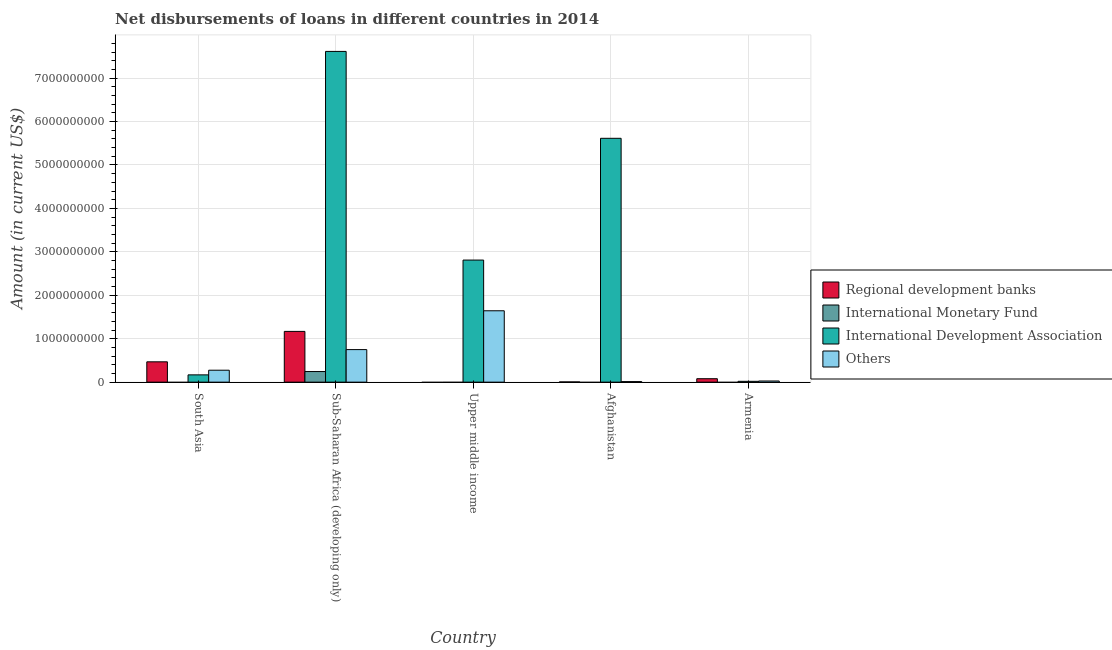How many different coloured bars are there?
Offer a very short reply. 4. How many groups of bars are there?
Your answer should be very brief. 5. Are the number of bars per tick equal to the number of legend labels?
Give a very brief answer. No. Are the number of bars on each tick of the X-axis equal?
Your answer should be very brief. No. What is the label of the 5th group of bars from the left?
Ensure brevity in your answer.  Armenia. What is the amount of loan disimbursed by international development association in Armenia?
Keep it short and to the point. 1.91e+07. Across all countries, what is the maximum amount of loan disimbursed by other organisations?
Provide a short and direct response. 1.64e+09. Across all countries, what is the minimum amount of loan disimbursed by other organisations?
Your answer should be compact. 1.25e+07. In which country was the amount of loan disimbursed by regional development banks maximum?
Provide a succinct answer. Sub-Saharan Africa (developing only). What is the total amount of loan disimbursed by regional development banks in the graph?
Give a very brief answer. 1.72e+09. What is the difference between the amount of loan disimbursed by other organisations in South Asia and that in Upper middle income?
Give a very brief answer. -1.37e+09. What is the difference between the amount of loan disimbursed by international development association in Upper middle income and the amount of loan disimbursed by regional development banks in Sub-Saharan Africa (developing only)?
Your answer should be very brief. 1.64e+09. What is the average amount of loan disimbursed by other organisations per country?
Offer a very short reply. 5.41e+08. What is the difference between the amount of loan disimbursed by other organisations and amount of loan disimbursed by regional development banks in Sub-Saharan Africa (developing only)?
Keep it short and to the point. -4.19e+08. In how many countries, is the amount of loan disimbursed by regional development banks greater than 1800000000 US$?
Offer a terse response. 0. What is the ratio of the amount of loan disimbursed by international development association in South Asia to that in Upper middle income?
Offer a terse response. 0.06. Is the amount of loan disimbursed by regional development banks in Afghanistan less than that in Sub-Saharan Africa (developing only)?
Give a very brief answer. Yes. What is the difference between the highest and the second highest amount of loan disimbursed by other organisations?
Make the answer very short. 8.94e+08. What is the difference between the highest and the lowest amount of loan disimbursed by international development association?
Make the answer very short. 7.59e+09. Is it the case that in every country, the sum of the amount of loan disimbursed by regional development banks and amount of loan disimbursed by international monetary fund is greater than the amount of loan disimbursed by international development association?
Your answer should be very brief. No. Does the graph contain any zero values?
Your answer should be very brief. Yes. Does the graph contain grids?
Give a very brief answer. Yes. Where does the legend appear in the graph?
Your response must be concise. Center right. What is the title of the graph?
Offer a terse response. Net disbursements of loans in different countries in 2014. Does "Budget management" appear as one of the legend labels in the graph?
Make the answer very short. No. What is the label or title of the Y-axis?
Provide a short and direct response. Amount (in current US$). What is the Amount (in current US$) of Regional development banks in South Asia?
Provide a short and direct response. 4.68e+08. What is the Amount (in current US$) in International Development Association in South Asia?
Ensure brevity in your answer.  1.68e+08. What is the Amount (in current US$) of Others in South Asia?
Make the answer very short. 2.75e+08. What is the Amount (in current US$) of Regional development banks in Sub-Saharan Africa (developing only)?
Make the answer very short. 1.17e+09. What is the Amount (in current US$) of International Monetary Fund in Sub-Saharan Africa (developing only)?
Ensure brevity in your answer.  2.44e+08. What is the Amount (in current US$) of International Development Association in Sub-Saharan Africa (developing only)?
Your answer should be compact. 7.61e+09. What is the Amount (in current US$) of Others in Sub-Saharan Africa (developing only)?
Your response must be concise. 7.49e+08. What is the Amount (in current US$) of International Monetary Fund in Upper middle income?
Provide a succinct answer. 0. What is the Amount (in current US$) in International Development Association in Upper middle income?
Ensure brevity in your answer.  2.81e+09. What is the Amount (in current US$) of Others in Upper middle income?
Offer a terse response. 1.64e+09. What is the Amount (in current US$) in Regional development banks in Afghanistan?
Offer a very short reply. 5.16e+06. What is the Amount (in current US$) in International Development Association in Afghanistan?
Offer a terse response. 5.61e+09. What is the Amount (in current US$) in Others in Afghanistan?
Provide a succinct answer. 1.25e+07. What is the Amount (in current US$) in Regional development banks in Armenia?
Offer a terse response. 7.92e+07. What is the Amount (in current US$) of International Development Association in Armenia?
Provide a short and direct response. 1.91e+07. What is the Amount (in current US$) in Others in Armenia?
Ensure brevity in your answer.  2.65e+07. Across all countries, what is the maximum Amount (in current US$) in Regional development banks?
Give a very brief answer. 1.17e+09. Across all countries, what is the maximum Amount (in current US$) of International Monetary Fund?
Offer a terse response. 2.44e+08. Across all countries, what is the maximum Amount (in current US$) in International Development Association?
Offer a terse response. 7.61e+09. Across all countries, what is the maximum Amount (in current US$) in Others?
Offer a very short reply. 1.64e+09. Across all countries, what is the minimum Amount (in current US$) in Regional development banks?
Ensure brevity in your answer.  0. Across all countries, what is the minimum Amount (in current US$) of International Development Association?
Provide a succinct answer. 1.91e+07. Across all countries, what is the minimum Amount (in current US$) in Others?
Ensure brevity in your answer.  1.25e+07. What is the total Amount (in current US$) in Regional development banks in the graph?
Offer a very short reply. 1.72e+09. What is the total Amount (in current US$) in International Monetary Fund in the graph?
Your answer should be very brief. 2.44e+08. What is the total Amount (in current US$) in International Development Association in the graph?
Give a very brief answer. 1.62e+1. What is the total Amount (in current US$) in Others in the graph?
Your answer should be very brief. 2.71e+09. What is the difference between the Amount (in current US$) in Regional development banks in South Asia and that in Sub-Saharan Africa (developing only)?
Provide a short and direct response. -7.01e+08. What is the difference between the Amount (in current US$) in International Development Association in South Asia and that in Sub-Saharan Africa (developing only)?
Offer a terse response. -7.45e+09. What is the difference between the Amount (in current US$) in Others in South Asia and that in Sub-Saharan Africa (developing only)?
Give a very brief answer. -4.75e+08. What is the difference between the Amount (in current US$) of International Development Association in South Asia and that in Upper middle income?
Ensure brevity in your answer.  -2.64e+09. What is the difference between the Amount (in current US$) in Others in South Asia and that in Upper middle income?
Keep it short and to the point. -1.37e+09. What is the difference between the Amount (in current US$) of Regional development banks in South Asia and that in Afghanistan?
Make the answer very short. 4.63e+08. What is the difference between the Amount (in current US$) of International Development Association in South Asia and that in Afghanistan?
Offer a very short reply. -5.45e+09. What is the difference between the Amount (in current US$) in Others in South Asia and that in Afghanistan?
Keep it short and to the point. 2.62e+08. What is the difference between the Amount (in current US$) of Regional development banks in South Asia and that in Armenia?
Provide a short and direct response. 3.89e+08. What is the difference between the Amount (in current US$) in International Development Association in South Asia and that in Armenia?
Your answer should be very brief. 1.49e+08. What is the difference between the Amount (in current US$) in Others in South Asia and that in Armenia?
Offer a very short reply. 2.48e+08. What is the difference between the Amount (in current US$) of International Development Association in Sub-Saharan Africa (developing only) and that in Upper middle income?
Ensure brevity in your answer.  4.80e+09. What is the difference between the Amount (in current US$) in Others in Sub-Saharan Africa (developing only) and that in Upper middle income?
Ensure brevity in your answer.  -8.94e+08. What is the difference between the Amount (in current US$) in Regional development banks in Sub-Saharan Africa (developing only) and that in Afghanistan?
Your response must be concise. 1.16e+09. What is the difference between the Amount (in current US$) in International Development Association in Sub-Saharan Africa (developing only) and that in Afghanistan?
Your response must be concise. 2.00e+09. What is the difference between the Amount (in current US$) in Others in Sub-Saharan Africa (developing only) and that in Afghanistan?
Provide a succinct answer. 7.37e+08. What is the difference between the Amount (in current US$) in Regional development banks in Sub-Saharan Africa (developing only) and that in Armenia?
Make the answer very short. 1.09e+09. What is the difference between the Amount (in current US$) of International Development Association in Sub-Saharan Africa (developing only) and that in Armenia?
Ensure brevity in your answer.  7.59e+09. What is the difference between the Amount (in current US$) in Others in Sub-Saharan Africa (developing only) and that in Armenia?
Your answer should be very brief. 7.23e+08. What is the difference between the Amount (in current US$) of International Development Association in Upper middle income and that in Afghanistan?
Provide a short and direct response. -2.80e+09. What is the difference between the Amount (in current US$) of Others in Upper middle income and that in Afghanistan?
Give a very brief answer. 1.63e+09. What is the difference between the Amount (in current US$) of International Development Association in Upper middle income and that in Armenia?
Offer a terse response. 2.79e+09. What is the difference between the Amount (in current US$) of Others in Upper middle income and that in Armenia?
Your response must be concise. 1.62e+09. What is the difference between the Amount (in current US$) in Regional development banks in Afghanistan and that in Armenia?
Provide a short and direct response. -7.40e+07. What is the difference between the Amount (in current US$) of International Development Association in Afghanistan and that in Armenia?
Make the answer very short. 5.59e+09. What is the difference between the Amount (in current US$) of Others in Afghanistan and that in Armenia?
Your response must be concise. -1.40e+07. What is the difference between the Amount (in current US$) in Regional development banks in South Asia and the Amount (in current US$) in International Monetary Fund in Sub-Saharan Africa (developing only)?
Provide a short and direct response. 2.24e+08. What is the difference between the Amount (in current US$) in Regional development banks in South Asia and the Amount (in current US$) in International Development Association in Sub-Saharan Africa (developing only)?
Your response must be concise. -7.15e+09. What is the difference between the Amount (in current US$) in Regional development banks in South Asia and the Amount (in current US$) in Others in Sub-Saharan Africa (developing only)?
Your answer should be compact. -2.82e+08. What is the difference between the Amount (in current US$) in International Development Association in South Asia and the Amount (in current US$) in Others in Sub-Saharan Africa (developing only)?
Make the answer very short. -5.82e+08. What is the difference between the Amount (in current US$) in Regional development banks in South Asia and the Amount (in current US$) in International Development Association in Upper middle income?
Offer a terse response. -2.34e+09. What is the difference between the Amount (in current US$) of Regional development banks in South Asia and the Amount (in current US$) of Others in Upper middle income?
Your response must be concise. -1.18e+09. What is the difference between the Amount (in current US$) of International Development Association in South Asia and the Amount (in current US$) of Others in Upper middle income?
Your answer should be very brief. -1.48e+09. What is the difference between the Amount (in current US$) of Regional development banks in South Asia and the Amount (in current US$) of International Development Association in Afghanistan?
Your answer should be compact. -5.15e+09. What is the difference between the Amount (in current US$) of Regional development banks in South Asia and the Amount (in current US$) of Others in Afghanistan?
Your response must be concise. 4.55e+08. What is the difference between the Amount (in current US$) of International Development Association in South Asia and the Amount (in current US$) of Others in Afghanistan?
Ensure brevity in your answer.  1.55e+08. What is the difference between the Amount (in current US$) in Regional development banks in South Asia and the Amount (in current US$) in International Development Association in Armenia?
Make the answer very short. 4.49e+08. What is the difference between the Amount (in current US$) of Regional development banks in South Asia and the Amount (in current US$) of Others in Armenia?
Your response must be concise. 4.41e+08. What is the difference between the Amount (in current US$) in International Development Association in South Asia and the Amount (in current US$) in Others in Armenia?
Offer a terse response. 1.41e+08. What is the difference between the Amount (in current US$) of Regional development banks in Sub-Saharan Africa (developing only) and the Amount (in current US$) of International Development Association in Upper middle income?
Your answer should be compact. -1.64e+09. What is the difference between the Amount (in current US$) in Regional development banks in Sub-Saharan Africa (developing only) and the Amount (in current US$) in Others in Upper middle income?
Your answer should be compact. -4.75e+08. What is the difference between the Amount (in current US$) of International Monetary Fund in Sub-Saharan Africa (developing only) and the Amount (in current US$) of International Development Association in Upper middle income?
Offer a terse response. -2.57e+09. What is the difference between the Amount (in current US$) in International Monetary Fund in Sub-Saharan Africa (developing only) and the Amount (in current US$) in Others in Upper middle income?
Your answer should be compact. -1.40e+09. What is the difference between the Amount (in current US$) in International Development Association in Sub-Saharan Africa (developing only) and the Amount (in current US$) in Others in Upper middle income?
Ensure brevity in your answer.  5.97e+09. What is the difference between the Amount (in current US$) in Regional development banks in Sub-Saharan Africa (developing only) and the Amount (in current US$) in International Development Association in Afghanistan?
Provide a short and direct response. -4.44e+09. What is the difference between the Amount (in current US$) of Regional development banks in Sub-Saharan Africa (developing only) and the Amount (in current US$) of Others in Afghanistan?
Keep it short and to the point. 1.16e+09. What is the difference between the Amount (in current US$) in International Monetary Fund in Sub-Saharan Africa (developing only) and the Amount (in current US$) in International Development Association in Afghanistan?
Ensure brevity in your answer.  -5.37e+09. What is the difference between the Amount (in current US$) in International Monetary Fund in Sub-Saharan Africa (developing only) and the Amount (in current US$) in Others in Afghanistan?
Your answer should be compact. 2.32e+08. What is the difference between the Amount (in current US$) of International Development Association in Sub-Saharan Africa (developing only) and the Amount (in current US$) of Others in Afghanistan?
Give a very brief answer. 7.60e+09. What is the difference between the Amount (in current US$) in Regional development banks in Sub-Saharan Africa (developing only) and the Amount (in current US$) in International Development Association in Armenia?
Offer a terse response. 1.15e+09. What is the difference between the Amount (in current US$) of Regional development banks in Sub-Saharan Africa (developing only) and the Amount (in current US$) of Others in Armenia?
Your answer should be compact. 1.14e+09. What is the difference between the Amount (in current US$) in International Monetary Fund in Sub-Saharan Africa (developing only) and the Amount (in current US$) in International Development Association in Armenia?
Your response must be concise. 2.25e+08. What is the difference between the Amount (in current US$) in International Monetary Fund in Sub-Saharan Africa (developing only) and the Amount (in current US$) in Others in Armenia?
Your answer should be compact. 2.18e+08. What is the difference between the Amount (in current US$) in International Development Association in Sub-Saharan Africa (developing only) and the Amount (in current US$) in Others in Armenia?
Your response must be concise. 7.59e+09. What is the difference between the Amount (in current US$) of International Development Association in Upper middle income and the Amount (in current US$) of Others in Afghanistan?
Ensure brevity in your answer.  2.80e+09. What is the difference between the Amount (in current US$) of International Development Association in Upper middle income and the Amount (in current US$) of Others in Armenia?
Give a very brief answer. 2.78e+09. What is the difference between the Amount (in current US$) of Regional development banks in Afghanistan and the Amount (in current US$) of International Development Association in Armenia?
Give a very brief answer. -1.39e+07. What is the difference between the Amount (in current US$) of Regional development banks in Afghanistan and the Amount (in current US$) of Others in Armenia?
Offer a terse response. -2.14e+07. What is the difference between the Amount (in current US$) of International Development Association in Afghanistan and the Amount (in current US$) of Others in Armenia?
Keep it short and to the point. 5.59e+09. What is the average Amount (in current US$) of Regional development banks per country?
Your response must be concise. 3.44e+08. What is the average Amount (in current US$) of International Monetary Fund per country?
Ensure brevity in your answer.  4.88e+07. What is the average Amount (in current US$) of International Development Association per country?
Make the answer very short. 3.24e+09. What is the average Amount (in current US$) in Others per country?
Make the answer very short. 5.41e+08. What is the difference between the Amount (in current US$) in Regional development banks and Amount (in current US$) in International Development Association in South Asia?
Your answer should be compact. 3.00e+08. What is the difference between the Amount (in current US$) in Regional development banks and Amount (in current US$) in Others in South Asia?
Your response must be concise. 1.93e+08. What is the difference between the Amount (in current US$) in International Development Association and Amount (in current US$) in Others in South Asia?
Offer a very short reply. -1.07e+08. What is the difference between the Amount (in current US$) in Regional development banks and Amount (in current US$) in International Monetary Fund in Sub-Saharan Africa (developing only)?
Your answer should be compact. 9.24e+08. What is the difference between the Amount (in current US$) in Regional development banks and Amount (in current US$) in International Development Association in Sub-Saharan Africa (developing only)?
Your answer should be compact. -6.45e+09. What is the difference between the Amount (in current US$) of Regional development banks and Amount (in current US$) of Others in Sub-Saharan Africa (developing only)?
Keep it short and to the point. 4.19e+08. What is the difference between the Amount (in current US$) in International Monetary Fund and Amount (in current US$) in International Development Association in Sub-Saharan Africa (developing only)?
Your response must be concise. -7.37e+09. What is the difference between the Amount (in current US$) of International Monetary Fund and Amount (in current US$) of Others in Sub-Saharan Africa (developing only)?
Keep it short and to the point. -5.05e+08. What is the difference between the Amount (in current US$) in International Development Association and Amount (in current US$) in Others in Sub-Saharan Africa (developing only)?
Make the answer very short. 6.86e+09. What is the difference between the Amount (in current US$) of International Development Association and Amount (in current US$) of Others in Upper middle income?
Keep it short and to the point. 1.17e+09. What is the difference between the Amount (in current US$) of Regional development banks and Amount (in current US$) of International Development Association in Afghanistan?
Provide a succinct answer. -5.61e+09. What is the difference between the Amount (in current US$) of Regional development banks and Amount (in current US$) of Others in Afghanistan?
Offer a terse response. -7.32e+06. What is the difference between the Amount (in current US$) of International Development Association and Amount (in current US$) of Others in Afghanistan?
Keep it short and to the point. 5.60e+09. What is the difference between the Amount (in current US$) in Regional development banks and Amount (in current US$) in International Development Association in Armenia?
Provide a succinct answer. 6.01e+07. What is the difference between the Amount (in current US$) of Regional development banks and Amount (in current US$) of Others in Armenia?
Provide a short and direct response. 5.26e+07. What is the difference between the Amount (in current US$) of International Development Association and Amount (in current US$) of Others in Armenia?
Provide a short and direct response. -7.43e+06. What is the ratio of the Amount (in current US$) in Regional development banks in South Asia to that in Sub-Saharan Africa (developing only)?
Your response must be concise. 0.4. What is the ratio of the Amount (in current US$) in International Development Association in South Asia to that in Sub-Saharan Africa (developing only)?
Offer a terse response. 0.02. What is the ratio of the Amount (in current US$) of Others in South Asia to that in Sub-Saharan Africa (developing only)?
Give a very brief answer. 0.37. What is the ratio of the Amount (in current US$) in International Development Association in South Asia to that in Upper middle income?
Offer a terse response. 0.06. What is the ratio of the Amount (in current US$) of Others in South Asia to that in Upper middle income?
Make the answer very short. 0.17. What is the ratio of the Amount (in current US$) of Regional development banks in South Asia to that in Afghanistan?
Your response must be concise. 90.75. What is the ratio of the Amount (in current US$) of International Development Association in South Asia to that in Afghanistan?
Ensure brevity in your answer.  0.03. What is the ratio of the Amount (in current US$) in Others in South Asia to that in Afghanistan?
Your answer should be very brief. 22.04. What is the ratio of the Amount (in current US$) of Regional development banks in South Asia to that in Armenia?
Provide a short and direct response. 5.91. What is the ratio of the Amount (in current US$) of International Development Association in South Asia to that in Armenia?
Offer a terse response. 8.78. What is the ratio of the Amount (in current US$) in Others in South Asia to that in Armenia?
Your response must be concise. 10.36. What is the ratio of the Amount (in current US$) of International Development Association in Sub-Saharan Africa (developing only) to that in Upper middle income?
Provide a short and direct response. 2.71. What is the ratio of the Amount (in current US$) of Others in Sub-Saharan Africa (developing only) to that in Upper middle income?
Give a very brief answer. 0.46. What is the ratio of the Amount (in current US$) in Regional development banks in Sub-Saharan Africa (developing only) to that in Afghanistan?
Your response must be concise. 226.66. What is the ratio of the Amount (in current US$) of International Development Association in Sub-Saharan Africa (developing only) to that in Afghanistan?
Your response must be concise. 1.36. What is the ratio of the Amount (in current US$) in Others in Sub-Saharan Africa (developing only) to that in Afghanistan?
Your response must be concise. 60.08. What is the ratio of the Amount (in current US$) of Regional development banks in Sub-Saharan Africa (developing only) to that in Armenia?
Give a very brief answer. 14.76. What is the ratio of the Amount (in current US$) in International Development Association in Sub-Saharan Africa (developing only) to that in Armenia?
Provide a short and direct response. 398.8. What is the ratio of the Amount (in current US$) of Others in Sub-Saharan Africa (developing only) to that in Armenia?
Ensure brevity in your answer.  28.26. What is the ratio of the Amount (in current US$) of International Development Association in Upper middle income to that in Afghanistan?
Make the answer very short. 0.5. What is the ratio of the Amount (in current US$) in Others in Upper middle income to that in Afghanistan?
Your answer should be compact. 131.73. What is the ratio of the Amount (in current US$) of International Development Association in Upper middle income to that in Armenia?
Provide a short and direct response. 147.2. What is the ratio of the Amount (in current US$) in Others in Upper middle income to that in Armenia?
Give a very brief answer. 61.95. What is the ratio of the Amount (in current US$) of Regional development banks in Afghanistan to that in Armenia?
Ensure brevity in your answer.  0.07. What is the ratio of the Amount (in current US$) in International Development Association in Afghanistan to that in Armenia?
Provide a short and direct response. 294.02. What is the ratio of the Amount (in current US$) in Others in Afghanistan to that in Armenia?
Ensure brevity in your answer.  0.47. What is the difference between the highest and the second highest Amount (in current US$) in Regional development banks?
Offer a terse response. 7.01e+08. What is the difference between the highest and the second highest Amount (in current US$) of International Development Association?
Keep it short and to the point. 2.00e+09. What is the difference between the highest and the second highest Amount (in current US$) in Others?
Your response must be concise. 8.94e+08. What is the difference between the highest and the lowest Amount (in current US$) in Regional development banks?
Your response must be concise. 1.17e+09. What is the difference between the highest and the lowest Amount (in current US$) in International Monetary Fund?
Ensure brevity in your answer.  2.44e+08. What is the difference between the highest and the lowest Amount (in current US$) in International Development Association?
Give a very brief answer. 7.59e+09. What is the difference between the highest and the lowest Amount (in current US$) in Others?
Your response must be concise. 1.63e+09. 